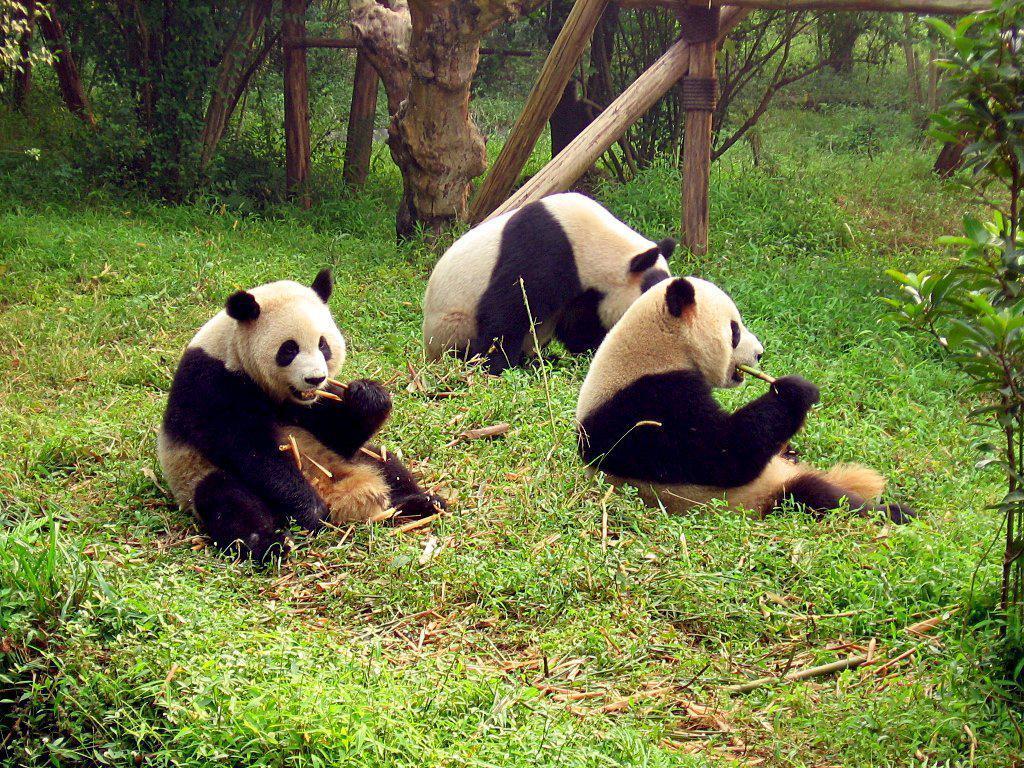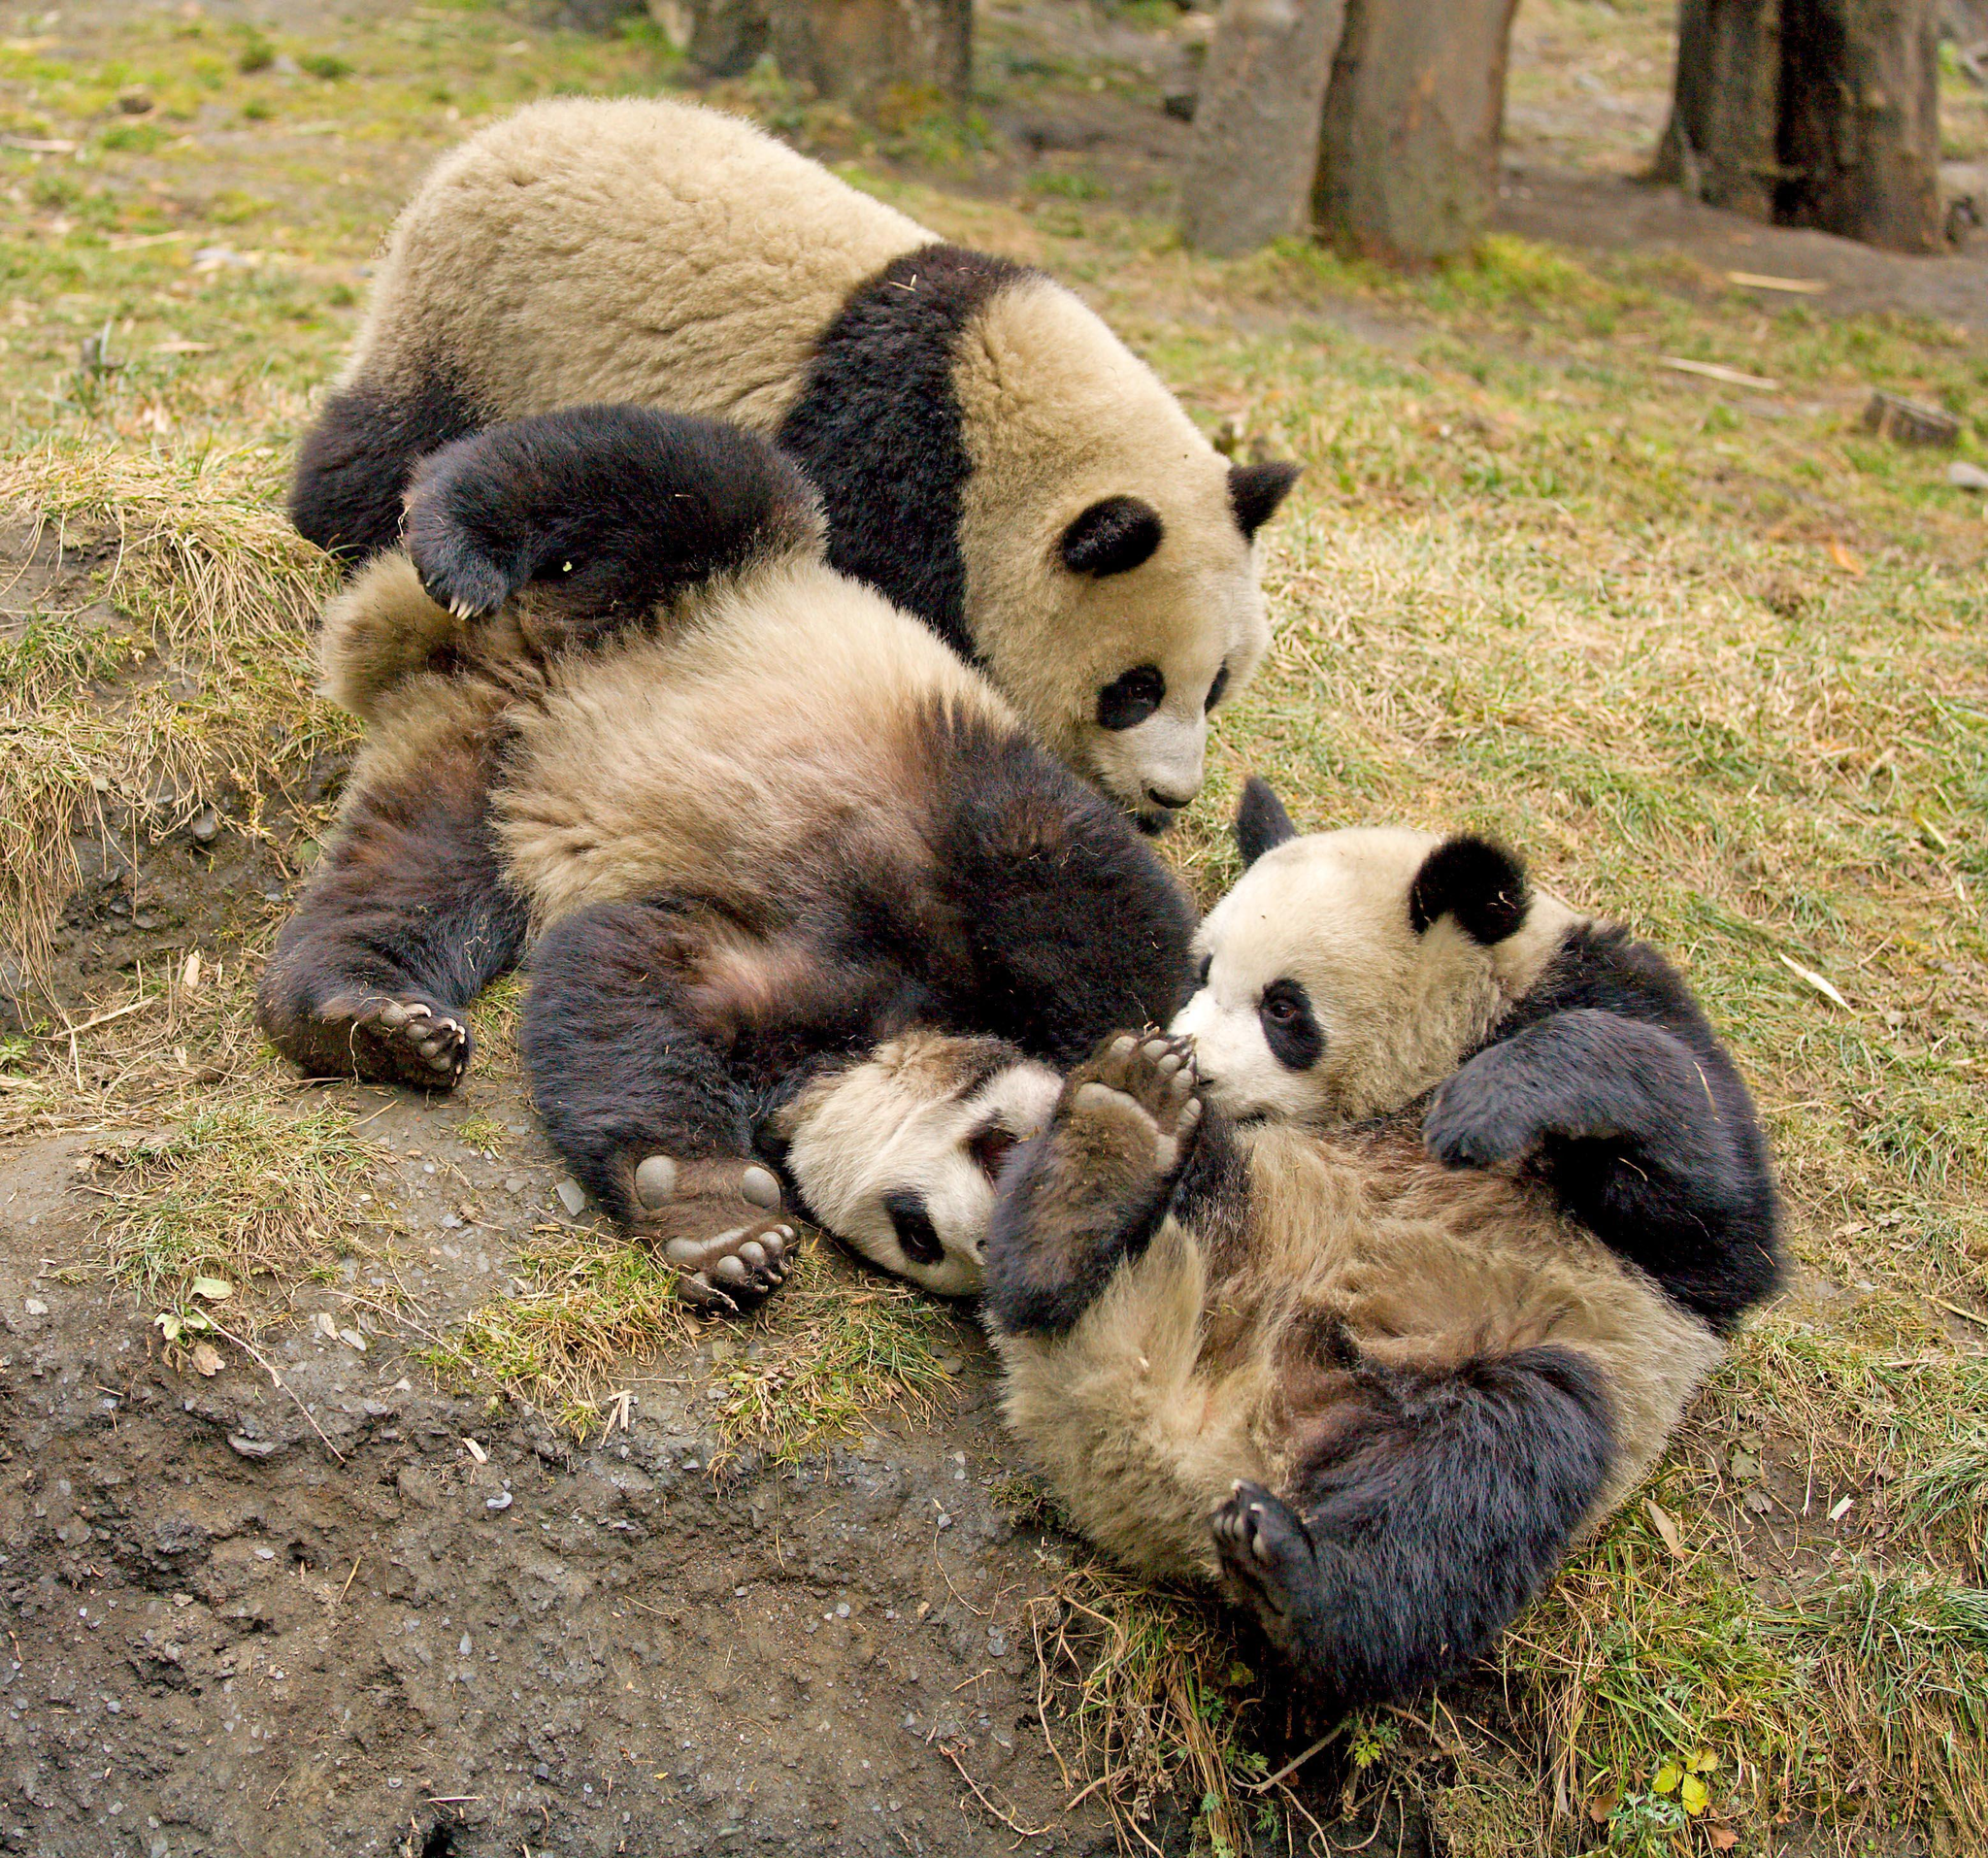The first image is the image on the left, the second image is the image on the right. Assess this claim about the two images: "One image shows a pair of pandas side-by-side in similar poses, and the other features just one panda.". Correct or not? Answer yes or no. No. The first image is the image on the left, the second image is the image on the right. Evaluate the accuracy of this statement regarding the images: "One giant panda is resting its chin on a log.". Is it true? Answer yes or no. No. 